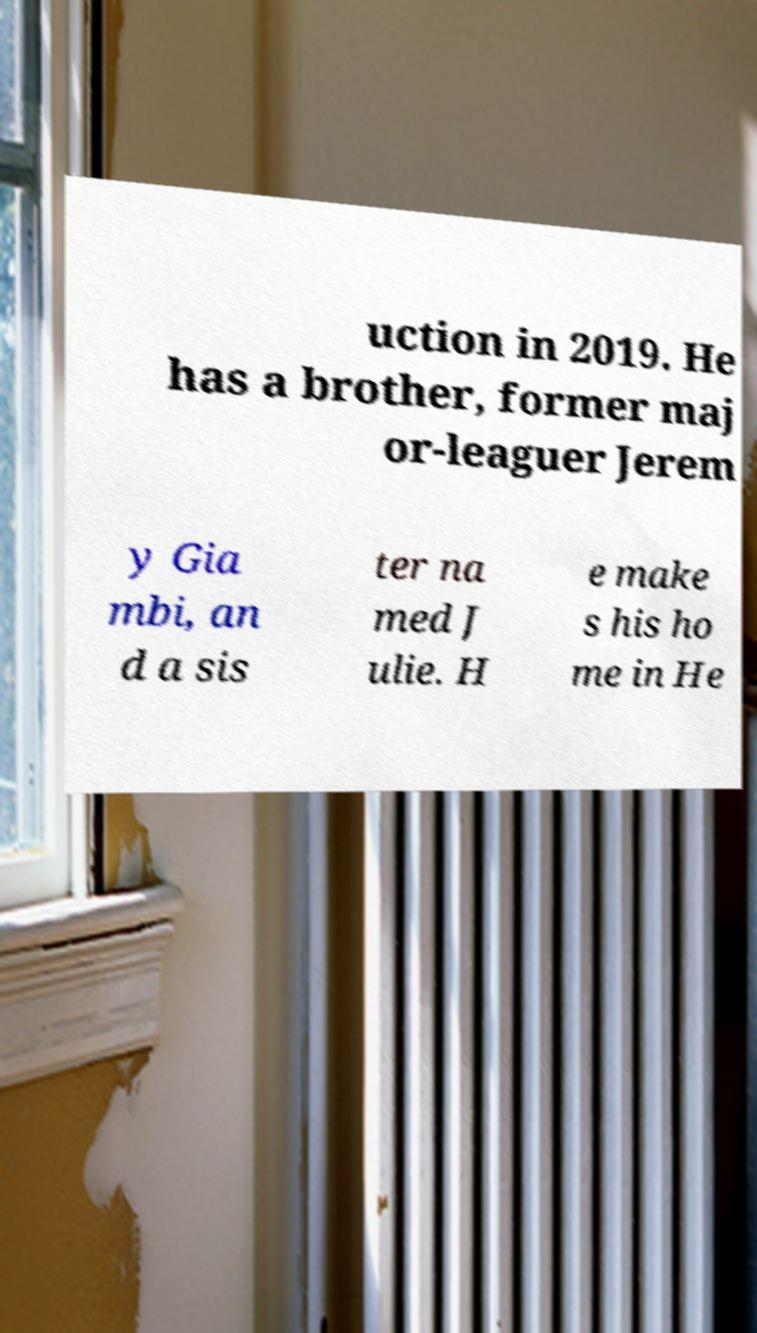Please read and relay the text visible in this image. What does it say? uction in 2019. He has a brother, former maj or-leaguer Jerem y Gia mbi, an d a sis ter na med J ulie. H e make s his ho me in He 